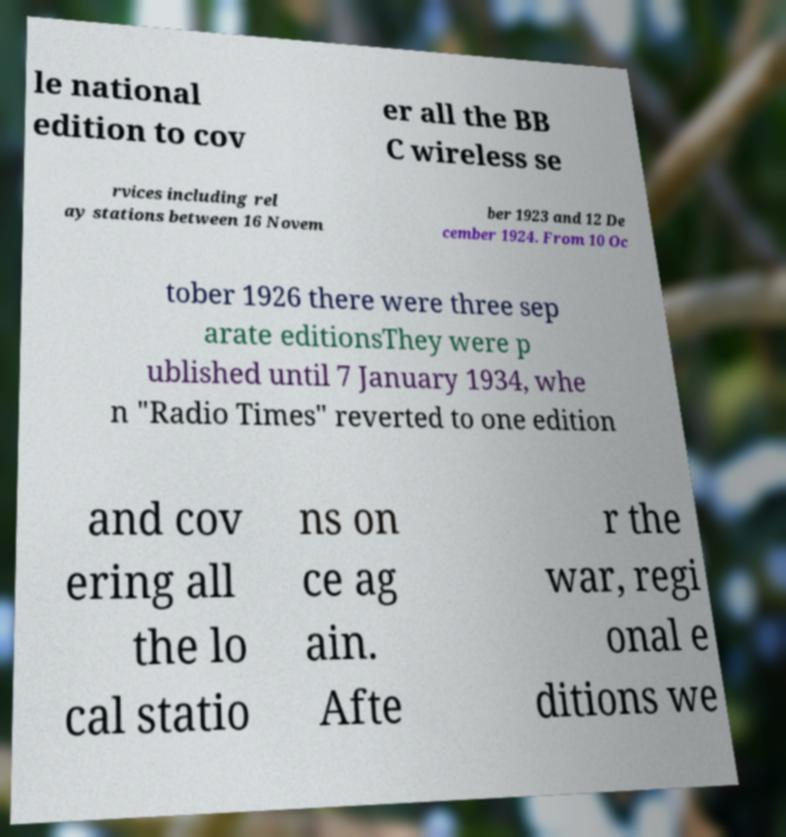I need the written content from this picture converted into text. Can you do that? le national edition to cov er all the BB C wireless se rvices including rel ay stations between 16 Novem ber 1923 and 12 De cember 1924. From 10 Oc tober 1926 there were three sep arate editionsThey were p ublished until 7 January 1934, whe n "Radio Times" reverted to one edition and cov ering all the lo cal statio ns on ce ag ain. Afte r the war, regi onal e ditions we 